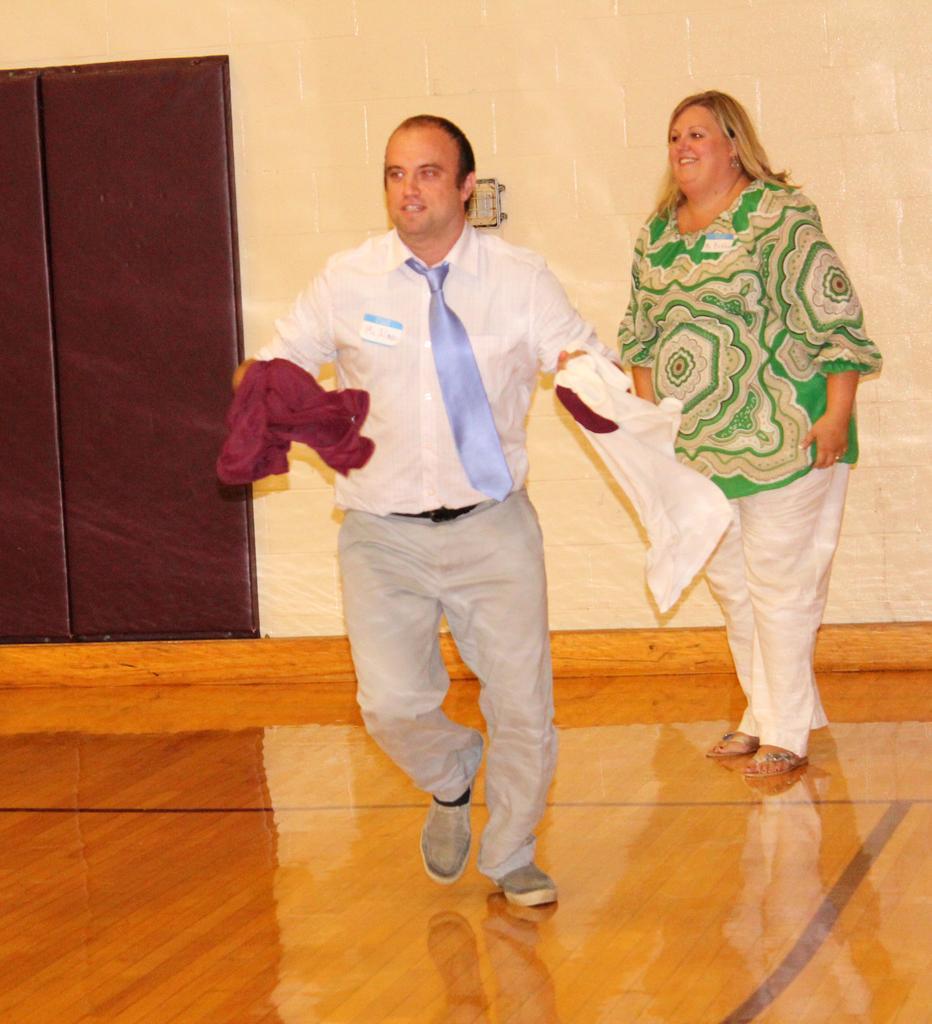In one or two sentences, can you explain what this image depicts? In the image in the center we can see two persons were standing and they were holding cloth. And we can see they were smiling,which we can see on their faces. In the background there is a wall,door and switch board. 